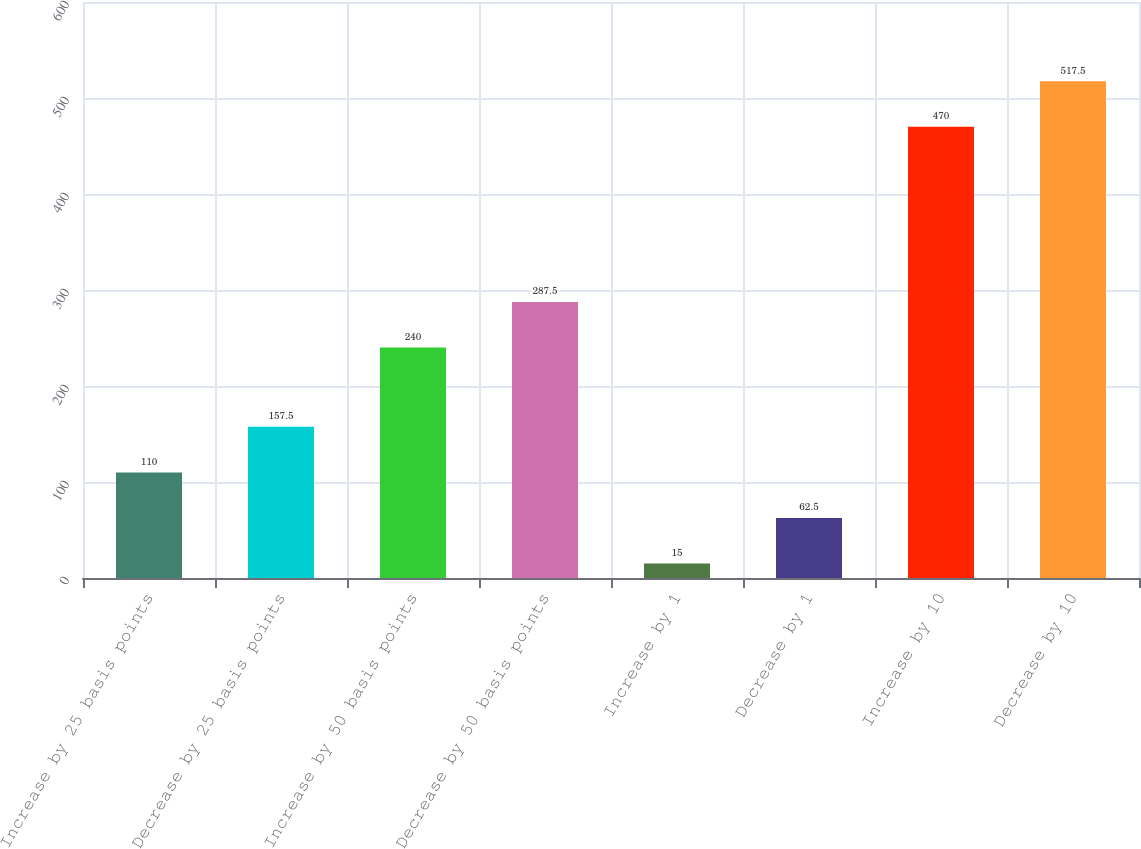<chart> <loc_0><loc_0><loc_500><loc_500><bar_chart><fcel>Increase by 25 basis points<fcel>Decrease by 25 basis points<fcel>Increase by 50 basis points<fcel>Decrease by 50 basis points<fcel>Increase by 1<fcel>Decrease by 1<fcel>Increase by 10<fcel>Decrease by 10<nl><fcel>110<fcel>157.5<fcel>240<fcel>287.5<fcel>15<fcel>62.5<fcel>470<fcel>517.5<nl></chart> 